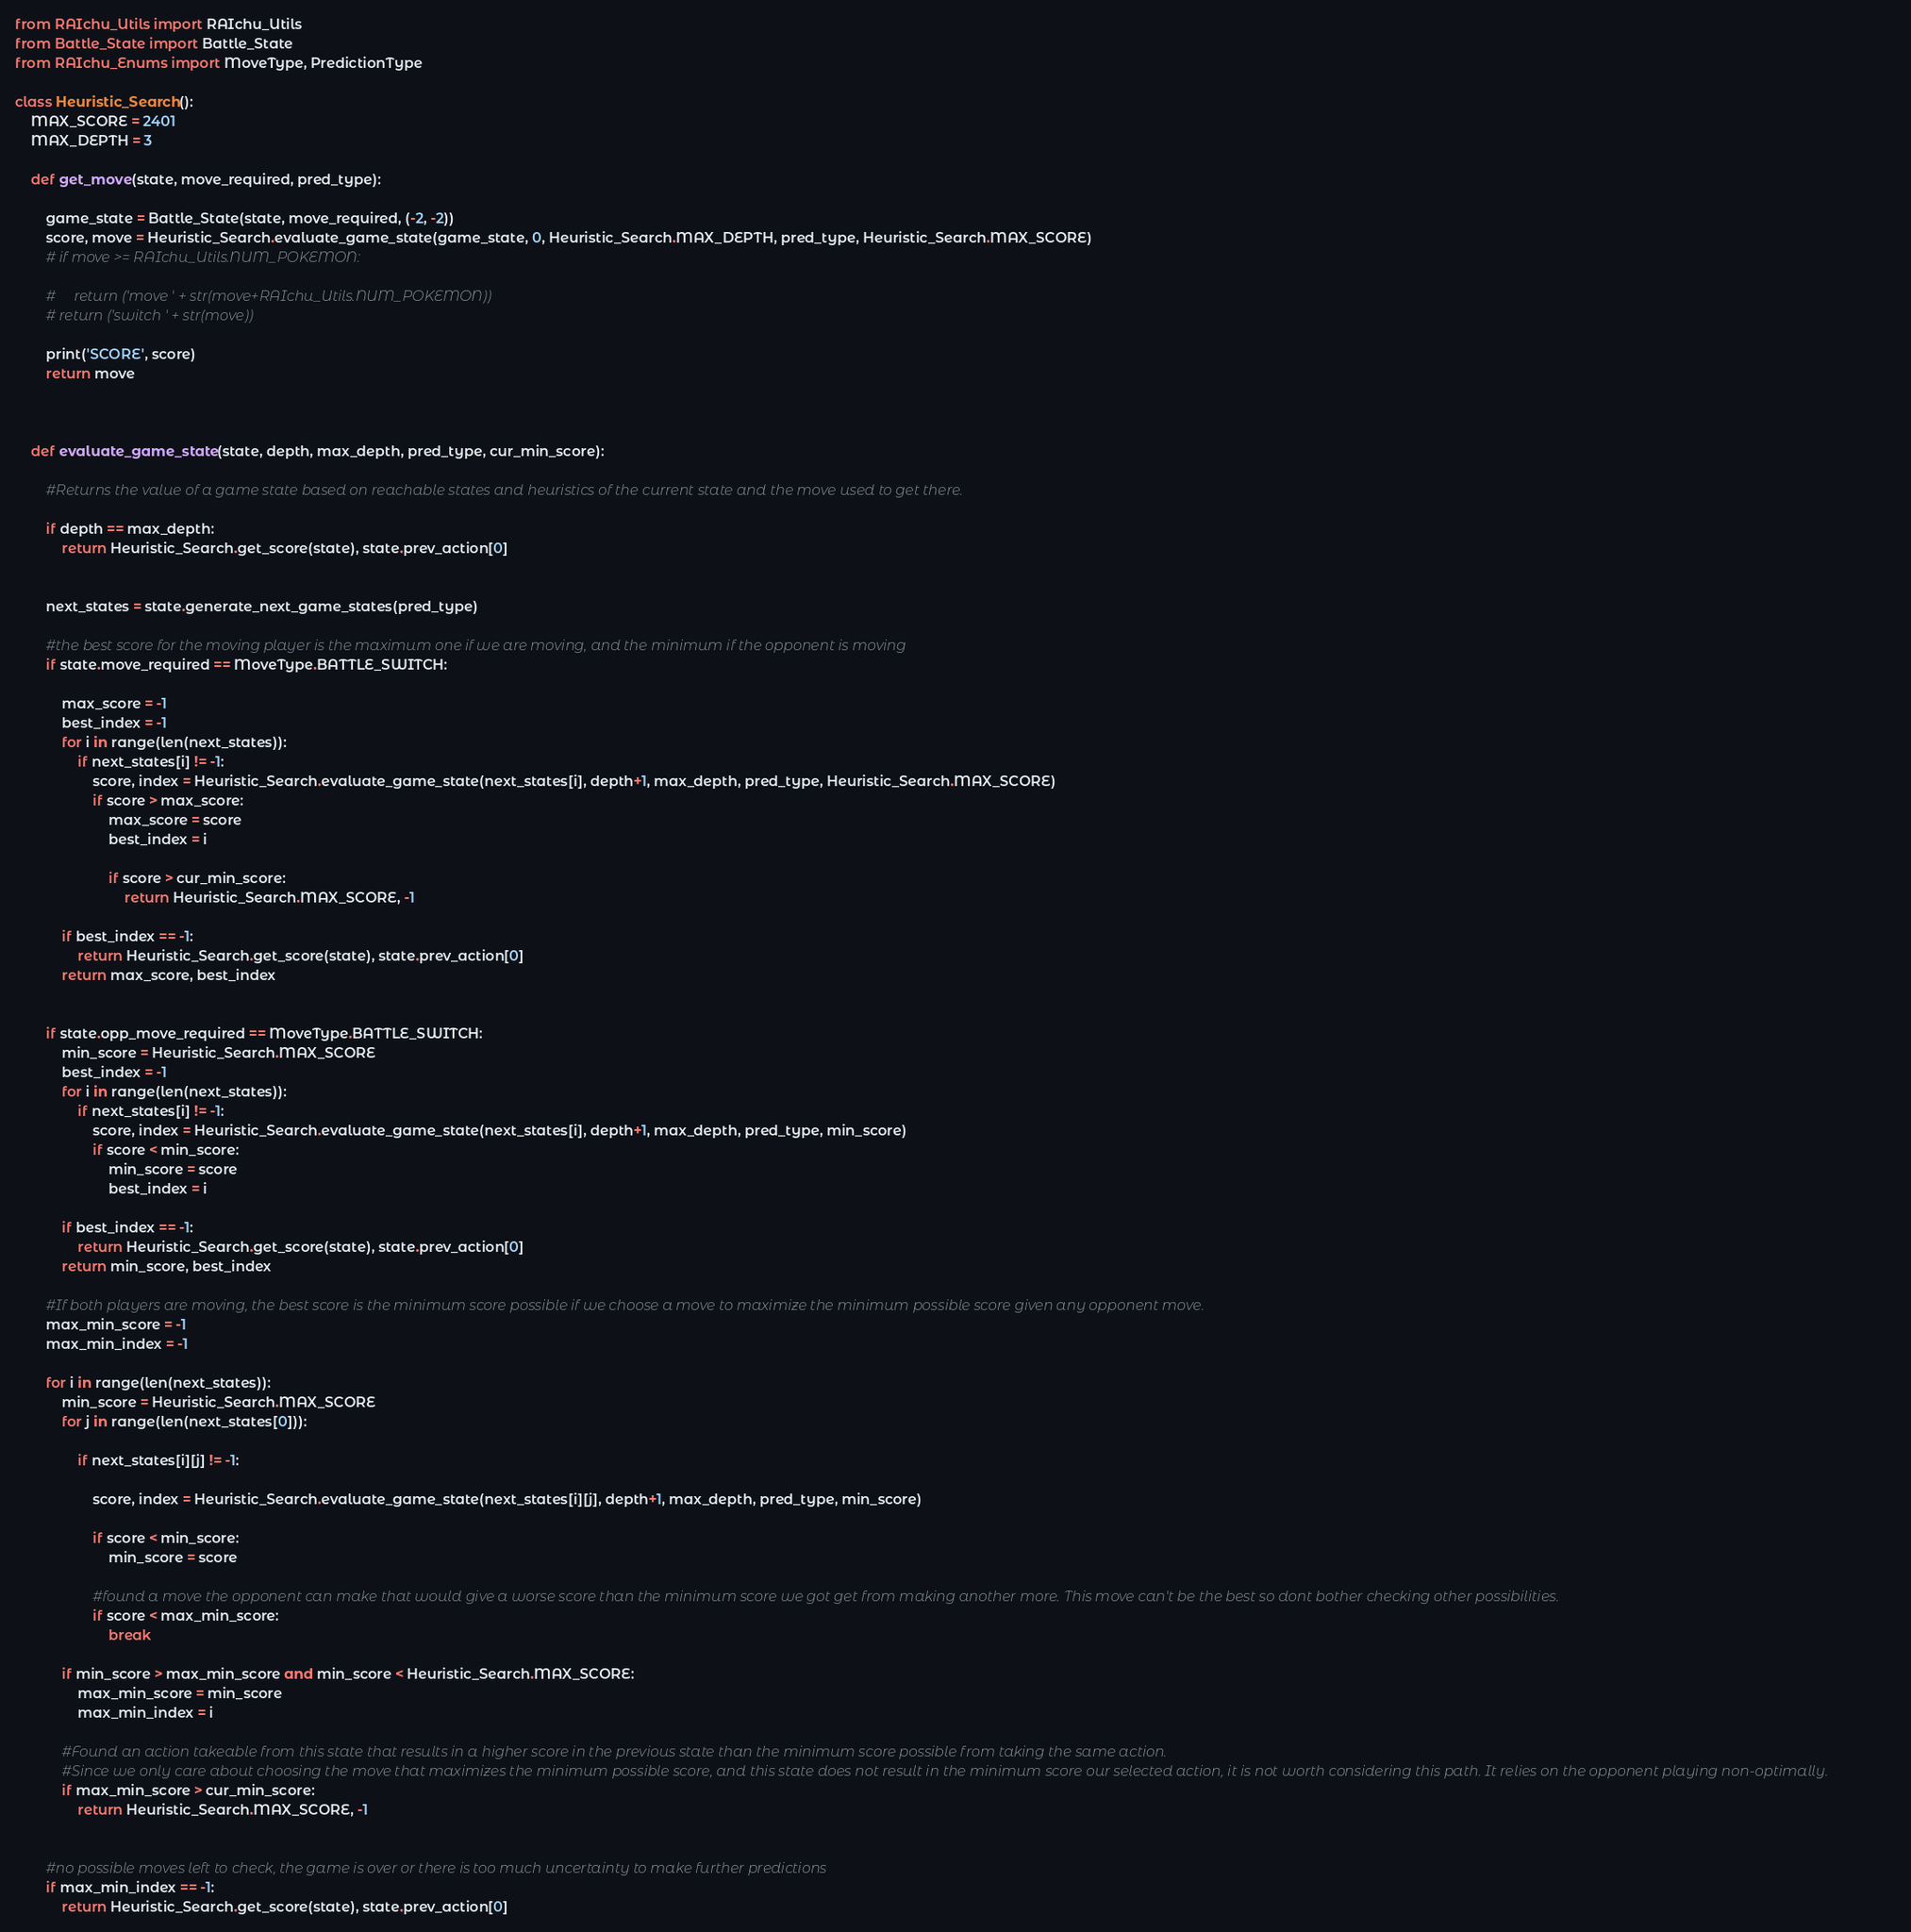Convert code to text. <code><loc_0><loc_0><loc_500><loc_500><_Python_>from RAIchu_Utils import RAIchu_Utils
from Battle_State import Battle_State
from RAIchu_Enums import MoveType, PredictionType

class Heuristic_Search():
    MAX_SCORE = 2401
    MAX_DEPTH = 3
    
    def get_move(state, move_required, pred_type):
        
        game_state = Battle_State(state, move_required, (-2, -2))
        score, move = Heuristic_Search.evaluate_game_state(game_state, 0, Heuristic_Search.MAX_DEPTH, pred_type, Heuristic_Search.MAX_SCORE)
        # if move >= RAIchu_Utils.NUM_POKEMON:
            
        #     return ('move ' + str(move+RAIchu_Utils.NUM_POKEMON))
        # return ('switch ' + str(move))
        
        print('SCORE', score)
        return move
    
    
    
    def evaluate_game_state(state, depth, max_depth, pred_type, cur_min_score):
        
        #Returns the value of a game state based on reachable states and heuristics of the current state and the move used to get there.
        
        if depth == max_depth:
            return Heuristic_Search.get_score(state), state.prev_action[0]
            
        
        next_states = state.generate_next_game_states(pred_type)
        
        #the best score for the moving player is the maximum one if we are moving, and the minimum if the opponent is moving
        if state.move_required == MoveType.BATTLE_SWITCH:
            
            max_score = -1
            best_index = -1
            for i in range(len(next_states)):
                if next_states[i] != -1:
                    score, index = Heuristic_Search.evaluate_game_state(next_states[i], depth+1, max_depth, pred_type, Heuristic_Search.MAX_SCORE)
                    if score > max_score:
                        max_score = score
                        best_index = i
                        
                        if score > cur_min_score:
                            return Heuristic_Search.MAX_SCORE, -1
            
            if best_index == -1:
                return Heuristic_Search.get_score(state), state.prev_action[0]
            return max_score, best_index
            
            
        if state.opp_move_required == MoveType.BATTLE_SWITCH:
            min_score = Heuristic_Search.MAX_SCORE
            best_index = -1
            for i in range(len(next_states)):
                if next_states[i] != -1:
                    score, index = Heuristic_Search.evaluate_game_state(next_states[i], depth+1, max_depth, pred_type, min_score)
                    if score < min_score:
                        min_score = score
                        best_index = i
            
            if best_index == -1:
                return Heuristic_Search.get_score(state), state.prev_action[0]
            return min_score, best_index
        
        #If both players are moving, the best score is the minimum score possible if we choose a move to maximize the minimum possible score given any opponent move.
        max_min_score = -1
        max_min_index = -1
        
        for i in range(len(next_states)):
            min_score = Heuristic_Search.MAX_SCORE
            for j in range(len(next_states[0])):
                
                if next_states[i][j] != -1:
                    
                    score, index = Heuristic_Search.evaluate_game_state(next_states[i][j], depth+1, max_depth, pred_type, min_score)

                    if score < min_score:
                        min_score = score
                        
                    #found a move the opponent can make that would give a worse score than the minimum score we got get from making another more. This move can't be the best so dont bother checking other possibilities.
                    if score < max_min_score:
                        break
                        
            if min_score > max_min_score and min_score < Heuristic_Search.MAX_SCORE:
                max_min_score = min_score
                max_min_index = i
                
            #Found an action takeable from this state that results in a higher score in the previous state than the minimum score possible from taking the same action.
            #Since we only care about choosing the move that maximizes the minimum possible score, and this state does not result in the minimum score our selected action, it is not worth considering this path. It relies on the opponent playing non-optimally. 
            if max_min_score > cur_min_score:
                return Heuristic_Search.MAX_SCORE, -1
                
                
        #no possible moves left to check, the game is over or there is too much uncertainty to make further predictions
        if max_min_index == -1:
            return Heuristic_Search.get_score(state), state.prev_action[0]</code> 